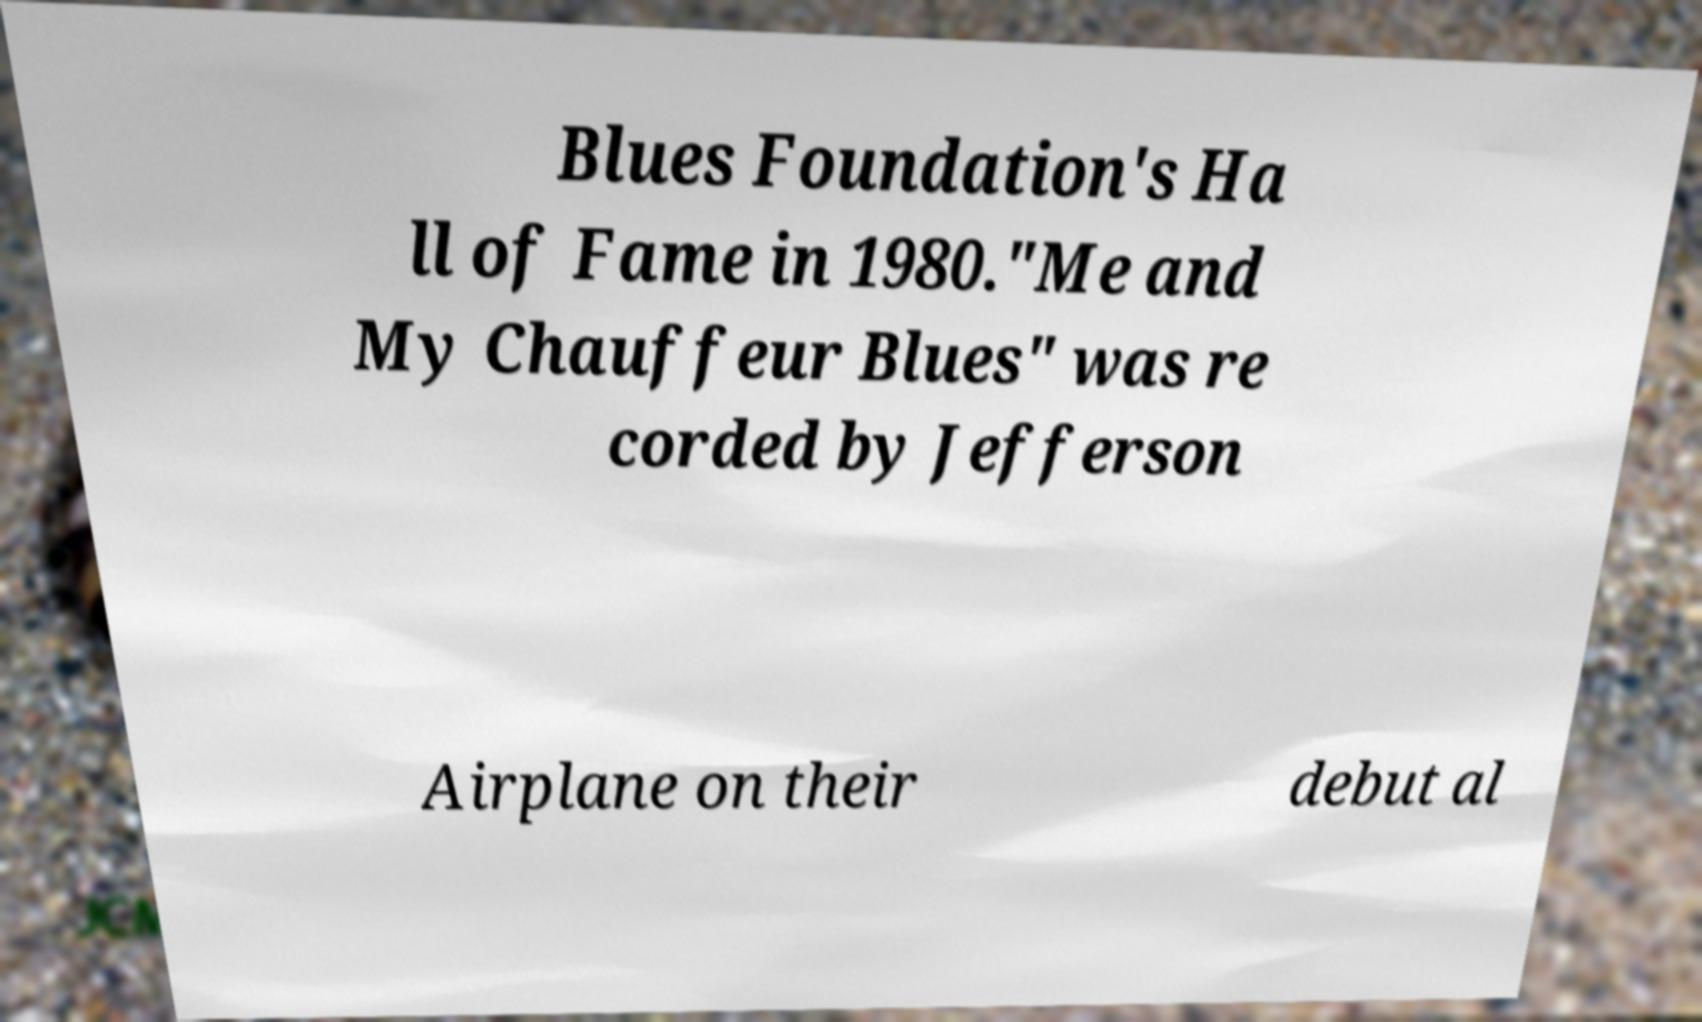Could you assist in decoding the text presented in this image and type it out clearly? Blues Foundation's Ha ll of Fame in 1980."Me and My Chauffeur Blues" was re corded by Jefferson Airplane on their debut al 